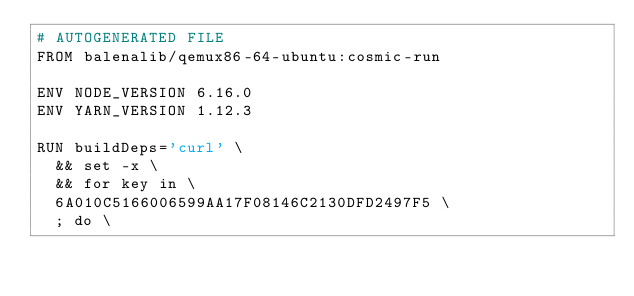Convert code to text. <code><loc_0><loc_0><loc_500><loc_500><_Dockerfile_># AUTOGENERATED FILE
FROM balenalib/qemux86-64-ubuntu:cosmic-run

ENV NODE_VERSION 6.16.0
ENV YARN_VERSION 1.12.3

RUN buildDeps='curl' \
	&& set -x \
	&& for key in \
	6A010C5166006599AA17F08146C2130DFD2497F5 \
	; do \</code> 